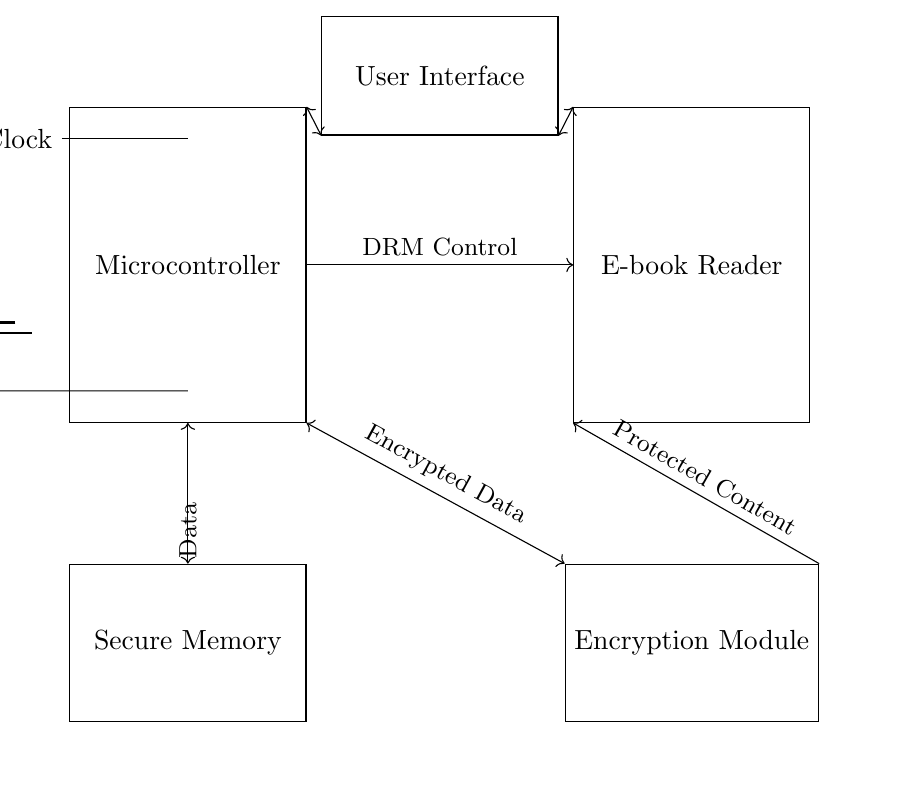What is the main function of the microcontroller in this circuit? The microcontroller controls the DRM functions, facilitating communication between the e-book reader and the secure memory.
Answer: DRM Control What stands out in the circuit diagram as a security component? The secure memory is explicitly designed for storing protected content, ensuring unauthorized access is limited.
Answer: Secure Memory What type of data does the encryption module handle? The encryption module processes encrypted data, which is a secure format that protects the content being read on the e-book reader.
Answer: Encrypted Data How many main components are directly connected to the microcontroller? The microcontroller has three main connections: one to the e-book reader, one to secure memory, and one to the encryption module.
Answer: Three Which component is responsible for user interaction in this circuit? The user interface is the designated component allowing users to interact with the microcontroller and the e-book reader seamlessly.
Answer: User Interface What role does the clock play in this circuit? The clock provides the necessary timing signals for the microcontroller to operate effectively and manage the data flow.
Answer: Clock What is the direction of data flow between the microcontroller and the encryption module? Data flows from the microcontroller to the encryption module, as indicated by the arrow, signifying a one-way data transfer for protection.
Answer: One-way to encryption module 